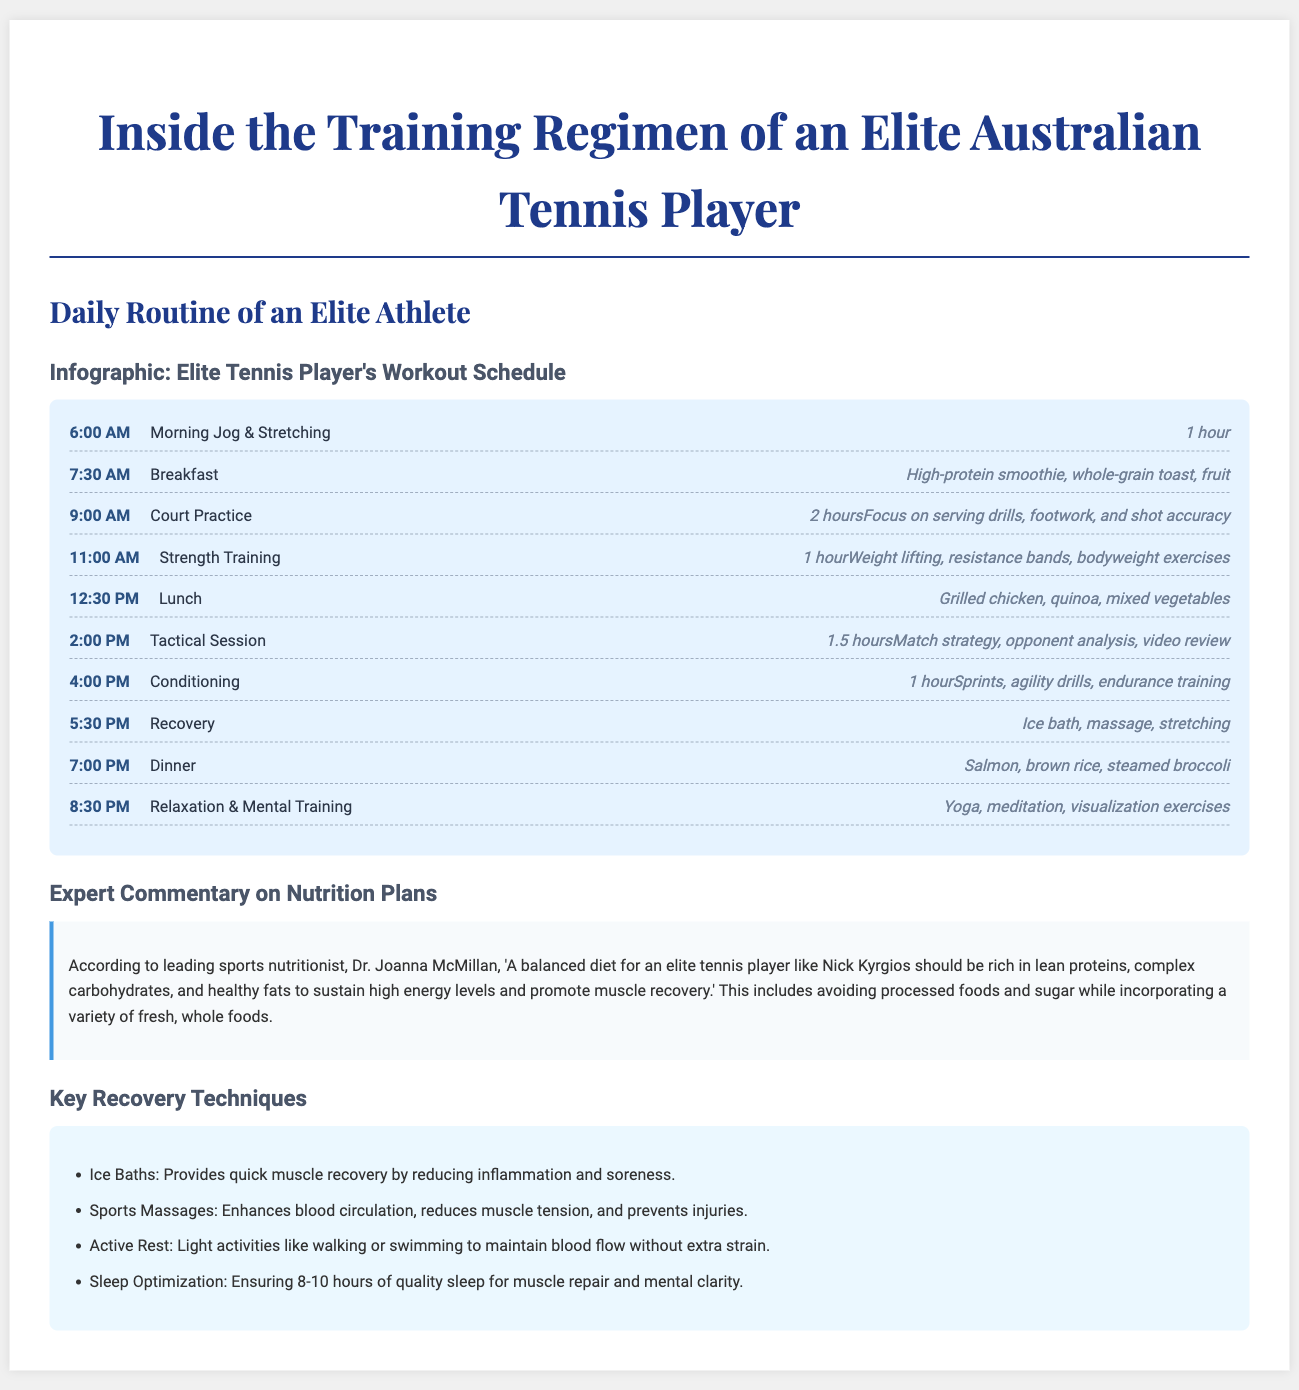What time does the morning jog start? The document lists the morning jog starting at 6:00 AM.
Answer: 6:00 AM How long is the court practice session? The court practice session is indicated as lasting 2 hours in the document.
Answer: 2 hours What is included in the breakfast? The document specifies that breakfast includes a high-protein smoothie, whole-grain toast, and fruit.
Answer: High-protein smoothie, whole-grain toast, fruit Who provided the expert commentary on nutrition plans? The expert commentary is provided by Dr. Joanna McMillan according to the document.
Answer: Dr. Joanna McMillan What type of recovery technique is related to muscle recovery? The document mentions ice baths as a recovery technique that provides quick muscle recovery.
Answer: Ice Baths What is a key component of the dinner meal? The dinner meal is specified in the document to include salmon.
Answer: Salmon How many hours of sleep are recommended for optimal recovery? The document states that 8-10 hours of quality sleep is recommended for muscle repair and mental clarity.
Answer: 8-10 hours What is the focus during the tactical session? The tactical session focuses on match strategy, opponent analysis, and video review as mentioned in the document.
Answer: Match strategy, opponent analysis, video review What kind of training is done at 4:00 PM? The 4:00 PM time slot is dedicated to conditioning training according to the workout schedule in the document.
Answer: Conditioning 